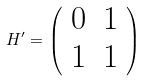<formula> <loc_0><loc_0><loc_500><loc_500>H ^ { \prime } = \left ( \begin{array} { c c } 0 & 1 \\ 1 & 1 \end{array} \right )</formula> 